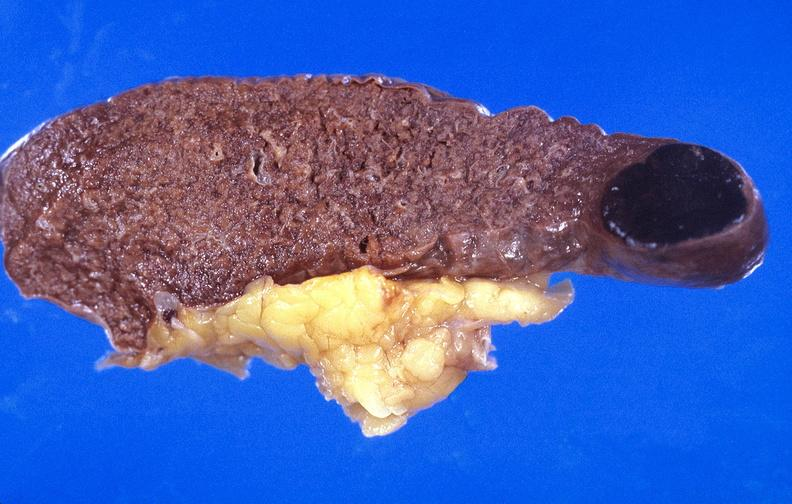does basilar skull fracture show spleen, metastasis of malignant melanoma?
Answer the question using a single word or phrase. No 